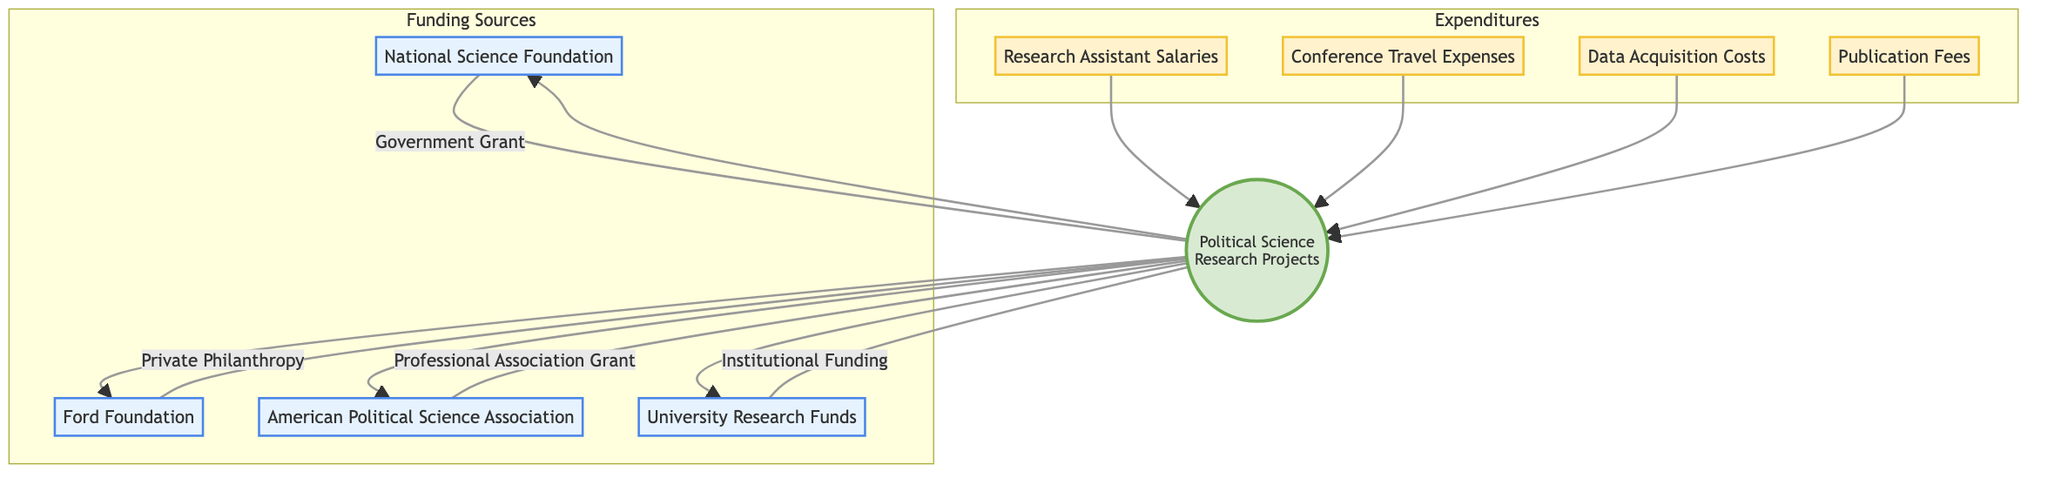What are the funding sources listed in the diagram? The diagram features four funding sources: National Science Foundation, Ford Foundation, American Political Science Association, and University Research Funds.
Answer: National Science Foundation, Ford Foundation, American Political Science Association, University Research Funds How many expenditure nodes are represented in the diagram? The diagram includes four expenditure nodes: Research Assistant Salaries, Conference Travel Expenses, Data Acquisition Costs, and Publication Fees. Therefore, the total number of expenditure nodes is four.
Answer: 4 Which funding source is categorized as a government grant? The funding source listed as a government grant is the National Science Foundation. To identify it, one can look at the type label attached to the National Science Foundation node, which states "Government Grant."
Answer: National Science Foundation What is the relationship between research assistant salaries and political science research projects? Research Assistant Salaries is directly connected to the central node "Political Science Research Projects," indicating that it is a type of expenditure supporting those projects. Thus, it shows a flow from the expenditure to the central project node.
Answer: Expenditure Which type of funding is associated with the American Political Science Association? The American Political Science Association is linked to the type "Professional Association Grant." This can be seen in the diagram by the label attached to the connection leading to the central node.
Answer: Professional Association Grant What are the expenditures that support political science research projects? The expenditures supporting political science research projects are Research Assistant Salaries, Conference Travel Expenses, Data Acquisition Costs, and Publication Fees, as indicated by the connections leading to the central node.
Answer: Research Assistant Salaries, Conference Travel Expenses, Data Acquisition Costs, Publication Fees How many funding sources are available in total? The diagram presents a total of four funding sources: National Science Foundation, Ford Foundation, American Political Science Association, and University Research Funds. Therefore, the count of funding sources is four.
Answer: 4 What type of funding sources are provided by the university? The type of funding that is sourced from the university is categorized as Institutional Funding, specifically represented by the University Research Funds node in the diagram.
Answer: Institutional Funding What is the purpose of the Ford Foundation as per the diagram? The Ford Foundation's purpose, as defined in the diagram, is to provide grants for social justice and political research projects. This can be directly obtained from the description attached to the Ford Foundation node.
Answer: Social justice and political research projects 